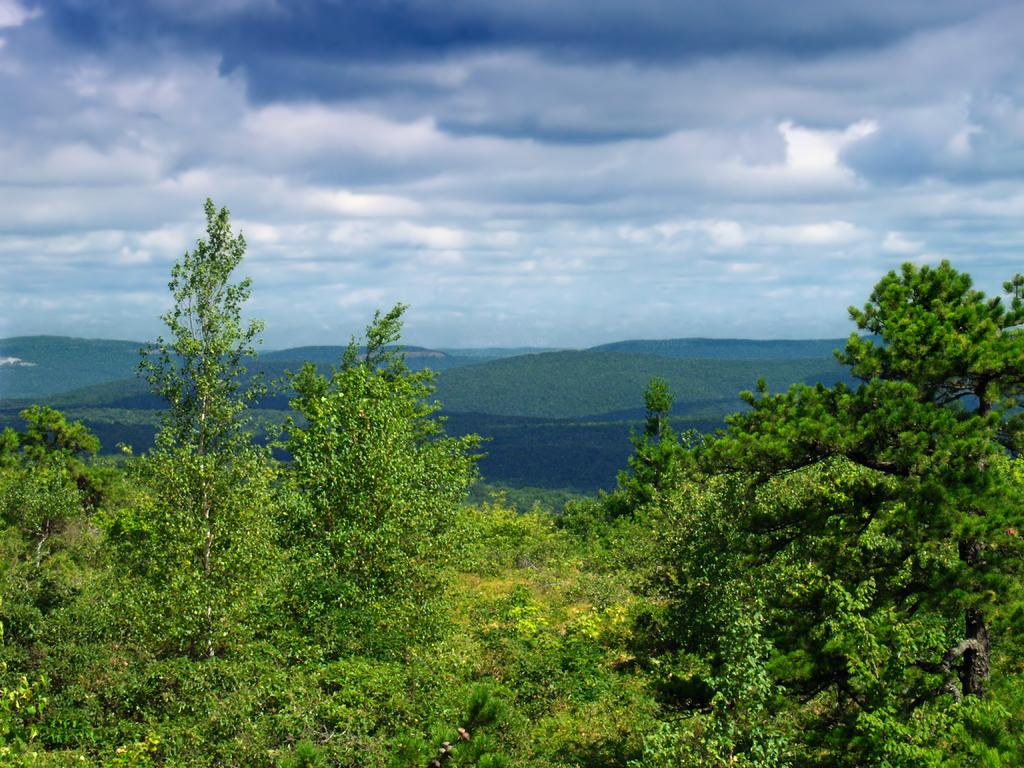What type of scenery is depicted in the image? The image contains a beautiful scenery. What type of vegetation can be seen in the image? There are trees and plants in the image. What geographical feature is present in the image? There are mountains in the image. Can you see any flames in the image? There are no flames present in the image. Is there a rabbit visible in the image? There is no rabbit present in the image. 